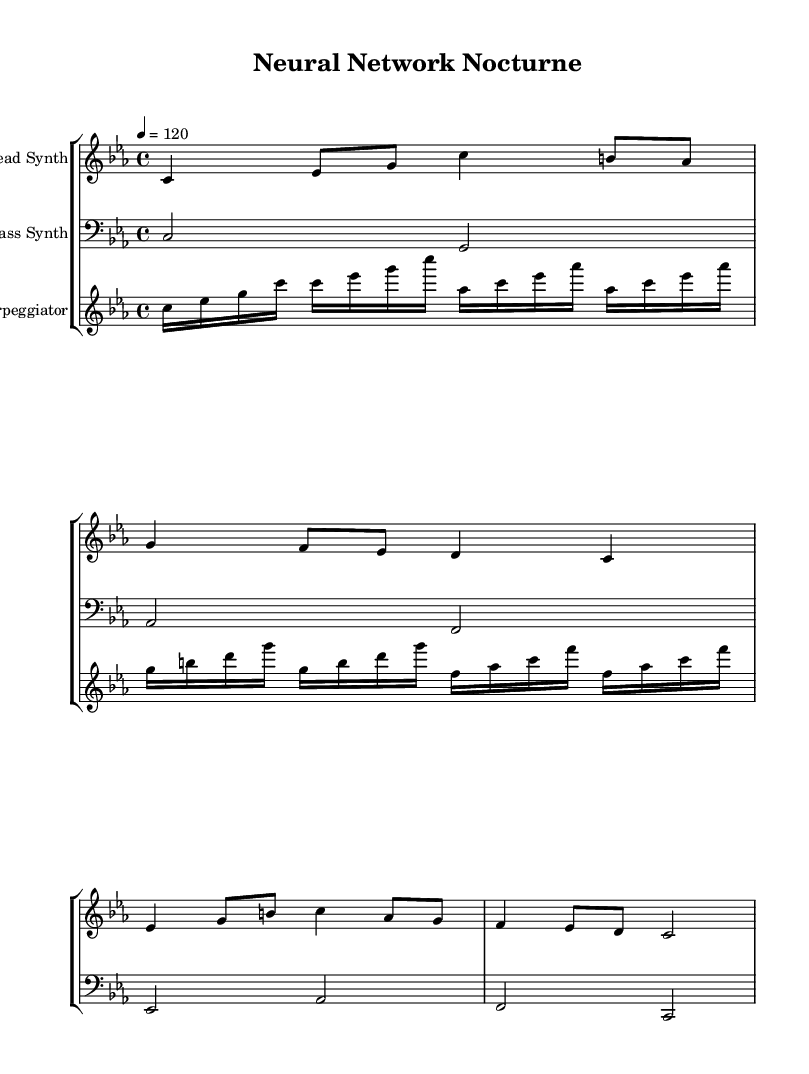what is the key signature of this music? The key signature is C minor, which has three flats (B flat, E flat, and A flat). This can be seen at the beginning of the music where the flats are indicated.
Answer: C minor what is the time signature of this piece? The time signature is 4/4, which is shown at the beginning of the sheet music after the key signature. This indicates that there are four beats in each measure and the quarter note gets one beat.
Answer: 4/4 what is the tempo marking of this piece? The tempo marking indicated at the beginning is 120, which means the quarter note should be played at a rate of 120 beats per minute. This is shown next to the tempo indication.
Answer: 120 how many staff members are present in this score? There are three staff members in this score: a lead synth, a bass synth, and an arpeggiator. Each staff is labeled at the beginning of the respective section.
Answer: 3 which synth plays the highest notes? The lead synth plays the highest notes as indicated by the use of the treble clef, which is typically used for higher pitch ranges, and the relative positioning of the notes shows that it plays notes above those in the bass synth.
Answer: Lead Synth what type of effects are represented by the arpeggiator in this piece? The arpeggiator mimics glitch effects typically found in cyberpunk music, as it plays a rapid sequence of notes rather than sustained chords, creating a fragmented sound. This is evident in the note patterns and rapid note values in this staff.
Answer: Glitch effects what is the rhythmic value of the majority of the lead synth notes? The majority of the lead synth notes are eighth notes, as seen in the rhythmic count of notes in the lead synth staff section where multiple eighth notes appear in measured patterns.
Answer: Eighth notes 